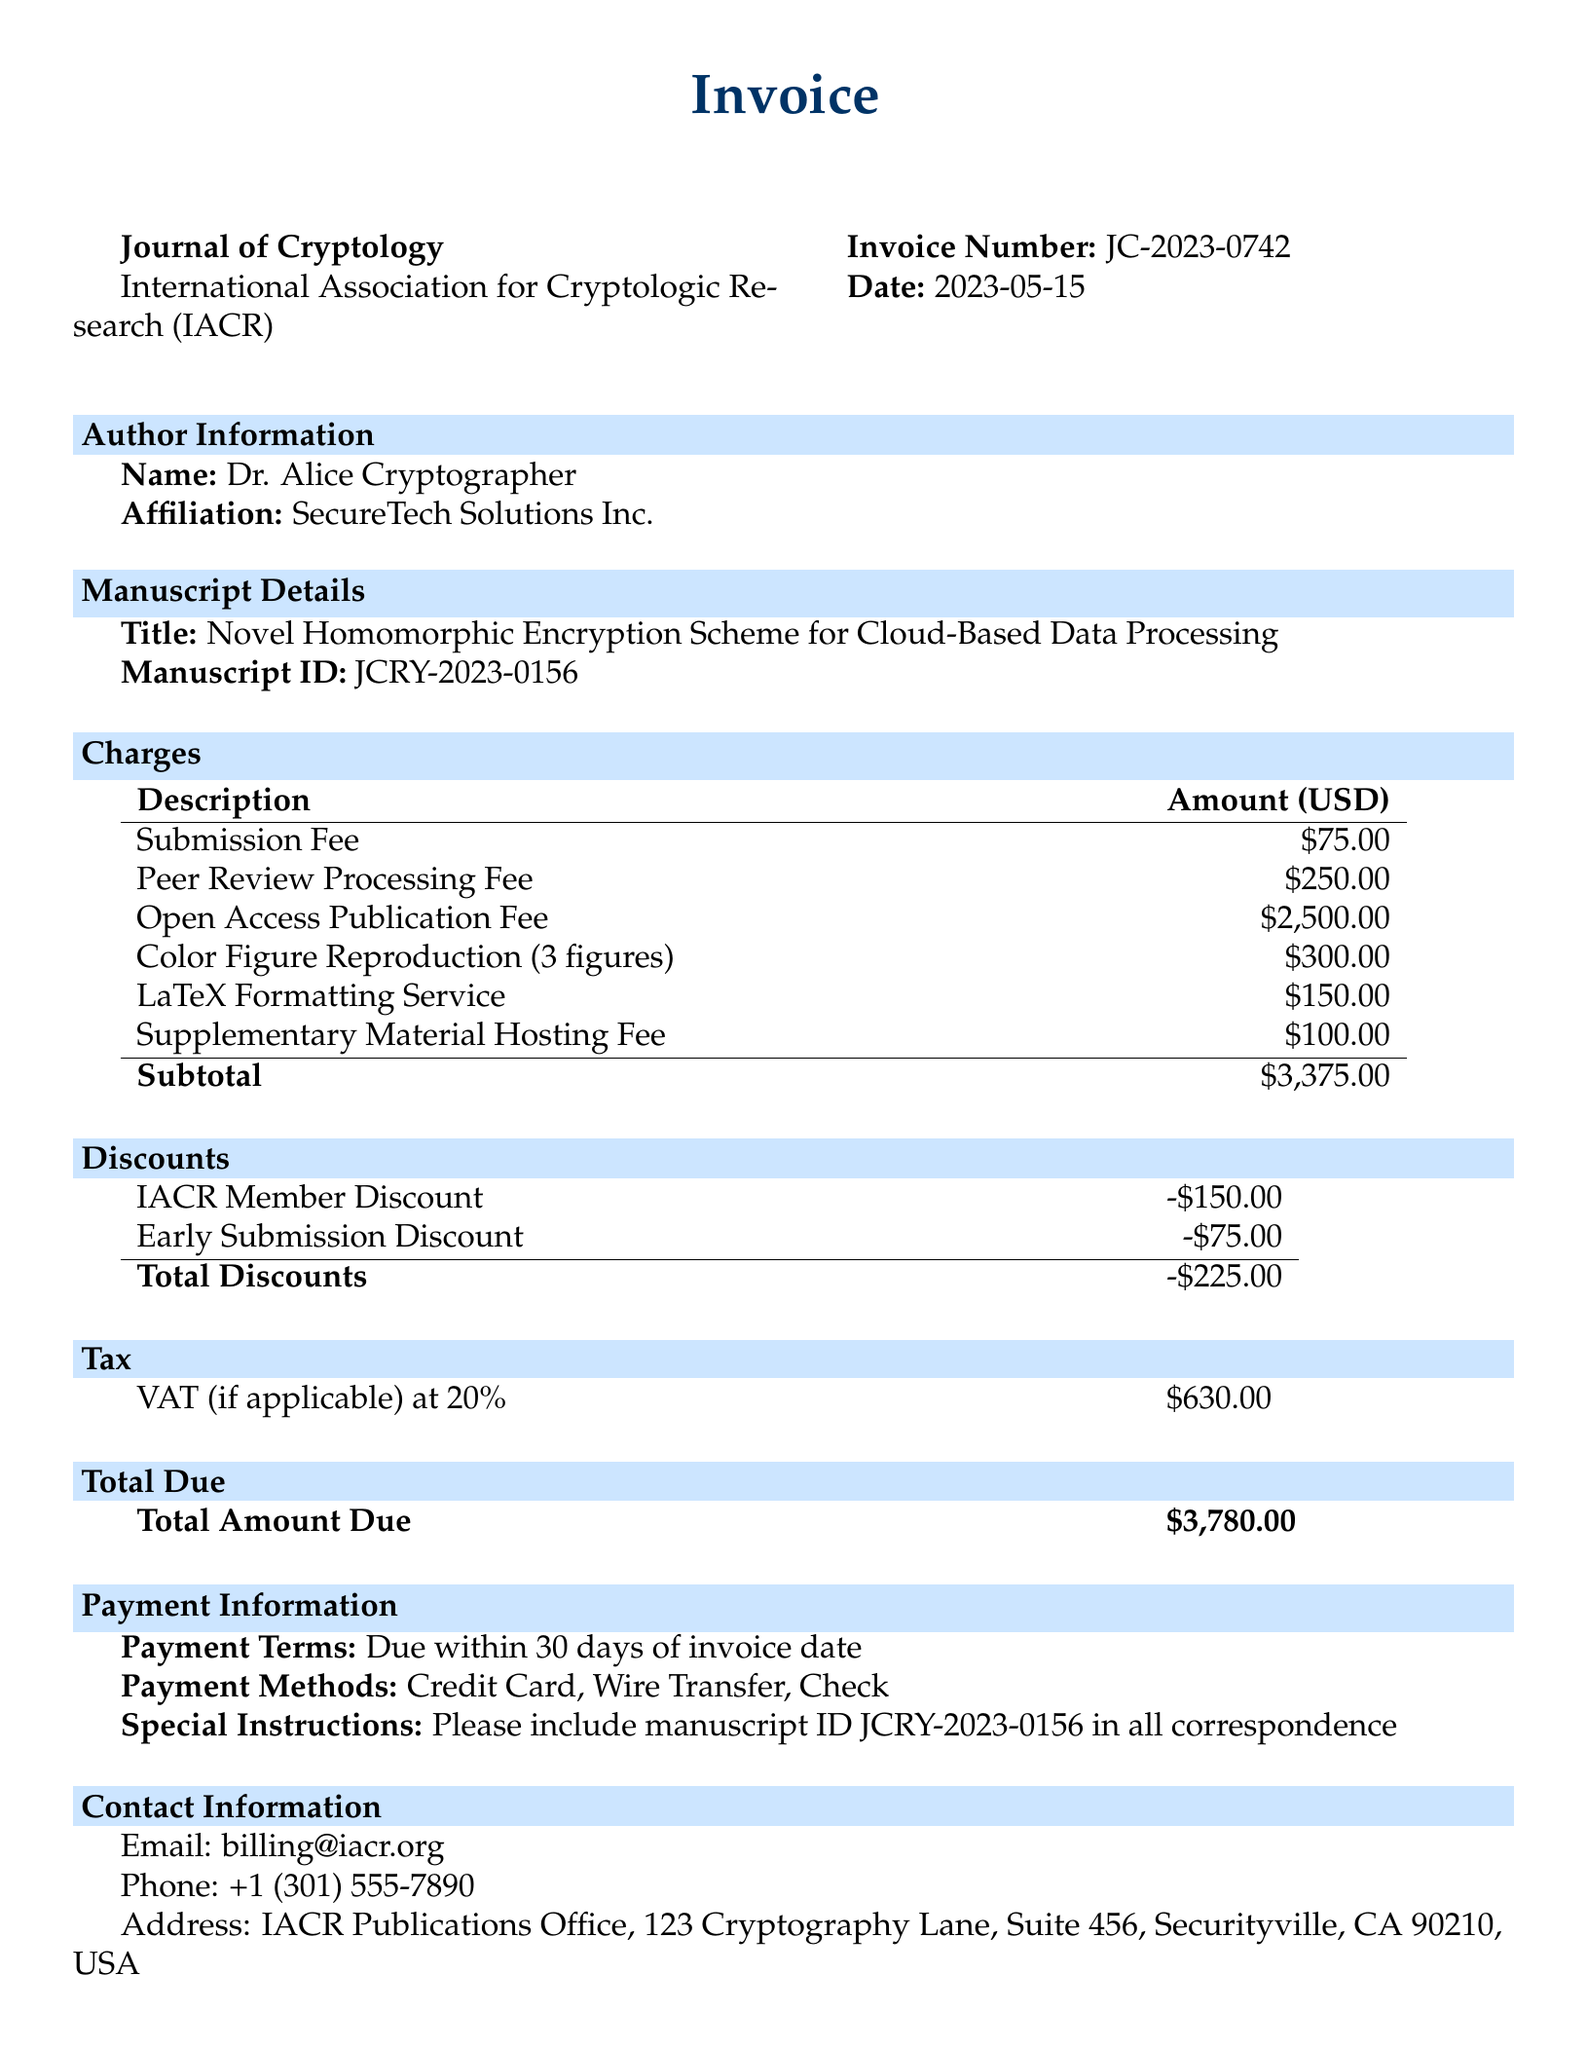What is the journal name? The journal name is specified in the document header section.
Answer: Journal of Cryptology Who is the author? The author's name is listed in the author information section.
Answer: Dr. Alice Cryptographer What is the total amount due? The total amount due is provided in the total due section of the invoice.
Answer: $3,780.00 What is the submission fee? The submission fee is one of the line items listed in the charges section.
Answer: $75.00 What is the VAT rate? The VAT rate is indicated in the tax section of the invoice.
Answer: 20% What discounts were applied? The discounts section outlines the discounts that were applied to the total.
Answer: IACR Member Discount, Early Submission Discount When is the payment due? The payment terms indicate when the payment is expected.
Answer: Due within 30 days of invoice date What payment methods are accepted? The payment methods are listed in the payment information section.
Answer: Credit Card, Wire Transfer, Check What figure reproduction charge is there? The charge for color figure reproduction is specified among the line items.
Answer: $300.00 